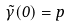Convert formula to latex. <formula><loc_0><loc_0><loc_500><loc_500>\tilde { \gamma } ( 0 ) = p</formula> 